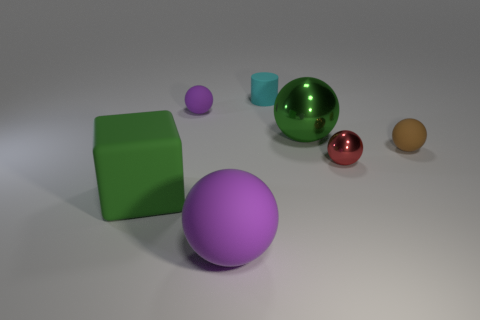Is there any other thing that is the same size as the matte cube?
Your answer should be very brief. Yes. There is a green metal object that is the same shape as the brown matte thing; what size is it?
Offer a terse response. Large. Is the number of rubber cylinders that are left of the cyan cylinder greater than the number of big matte things to the left of the big purple rubber object?
Provide a succinct answer. No. Is the tiny cylinder made of the same material as the purple sphere that is in front of the tiny brown rubber sphere?
Your response must be concise. Yes. Is there any other thing that has the same shape as the tiny cyan object?
Offer a very short reply. No. What color is the small object that is both left of the tiny brown object and to the right of the tiny matte cylinder?
Ensure brevity in your answer.  Red. There is a green thing right of the cyan matte cylinder; what shape is it?
Provide a succinct answer. Sphere. How big is the purple ball to the left of the matte ball that is in front of the brown thing to the right of the rubber cylinder?
Provide a succinct answer. Small. What number of purple things are in front of the tiny matte ball that is right of the small purple object?
Offer a very short reply. 1. There is a ball that is both in front of the tiny brown matte thing and behind the rubber block; what size is it?
Give a very brief answer. Small. 